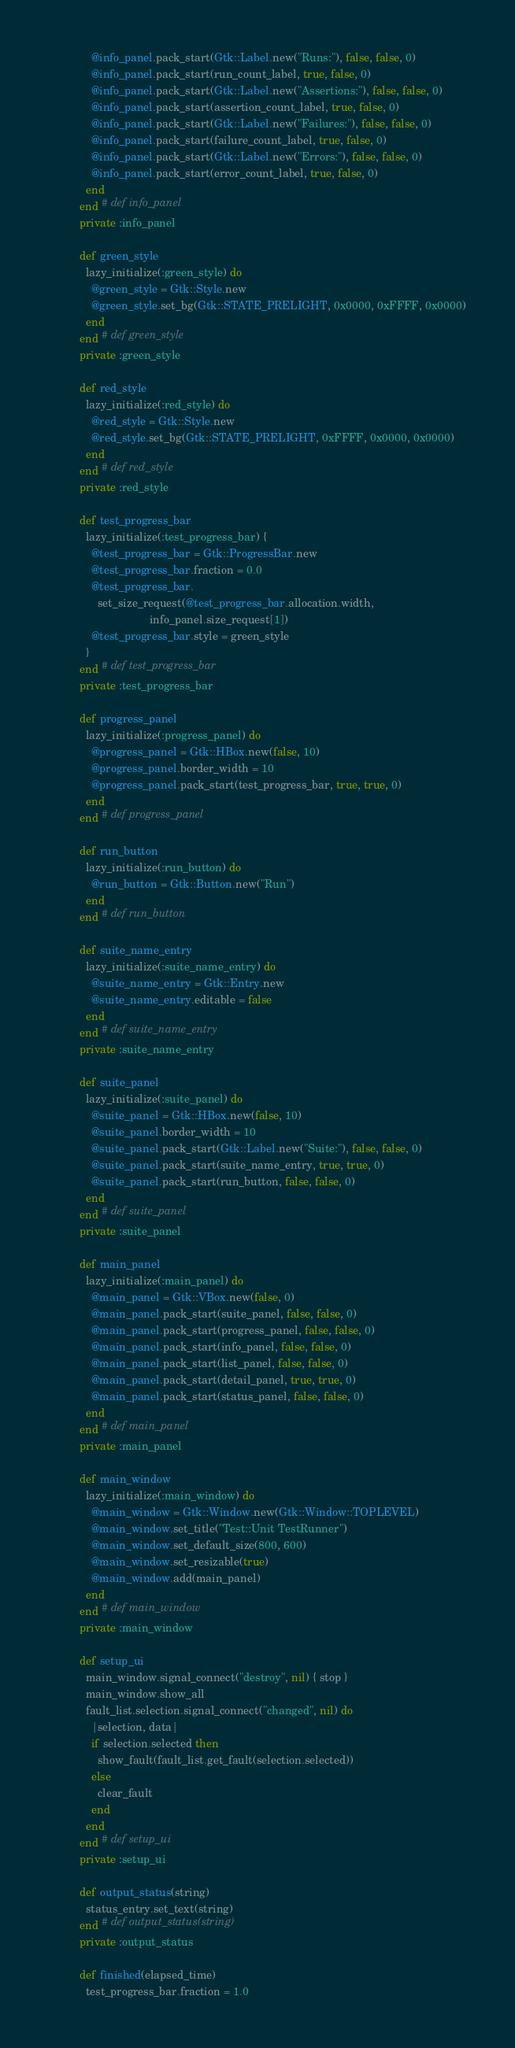Convert code to text. <code><loc_0><loc_0><loc_500><loc_500><_Ruby_>              @info_panel.pack_start(Gtk::Label.new("Runs:"), false, false, 0)
              @info_panel.pack_start(run_count_label, true, false, 0)
              @info_panel.pack_start(Gtk::Label.new("Assertions:"), false, false, 0)
              @info_panel.pack_start(assertion_count_label, true, false, 0)
              @info_panel.pack_start(Gtk::Label.new("Failures:"), false, false, 0)
              @info_panel.pack_start(failure_count_label, true, false, 0)
              @info_panel.pack_start(Gtk::Label.new("Errors:"), false, false, 0)
              @info_panel.pack_start(error_count_label, true, false, 0)
            end
          end # def info_panel
          private :info_panel

          def green_style
            lazy_initialize(:green_style) do
              @green_style = Gtk::Style.new
              @green_style.set_bg(Gtk::STATE_PRELIGHT, 0x0000, 0xFFFF, 0x0000)
            end
          end # def green_style
          private :green_style
          
          def red_style
            lazy_initialize(:red_style) do
              @red_style = Gtk::Style.new
              @red_style.set_bg(Gtk::STATE_PRELIGHT, 0xFFFF, 0x0000, 0x0000)
            end
          end # def red_style
          private :red_style
          
          def test_progress_bar
            lazy_initialize(:test_progress_bar) {
              @test_progress_bar = Gtk::ProgressBar.new
              @test_progress_bar.fraction = 0.0
              @test_progress_bar.
                set_size_request(@test_progress_bar.allocation.width,
                                 info_panel.size_request[1])
              @test_progress_bar.style = green_style
            }
          end # def test_progress_bar
          private :test_progress_bar
          
          def progress_panel
            lazy_initialize(:progress_panel) do
              @progress_panel = Gtk::HBox.new(false, 10)
              @progress_panel.border_width = 10
              @progress_panel.pack_start(test_progress_bar, true, true, 0)
            end
          end # def progress_panel

          def run_button
            lazy_initialize(:run_button) do
              @run_button = Gtk::Button.new("Run")
            end
          end # def run_button

          def suite_name_entry
            lazy_initialize(:suite_name_entry) do
              @suite_name_entry = Gtk::Entry.new
              @suite_name_entry.editable = false
            end
          end # def suite_name_entry
          private :suite_name_entry

          def suite_panel
            lazy_initialize(:suite_panel) do
              @suite_panel = Gtk::HBox.new(false, 10)
              @suite_panel.border_width = 10
              @suite_panel.pack_start(Gtk::Label.new("Suite:"), false, false, 0)
              @suite_panel.pack_start(suite_name_entry, true, true, 0)
              @suite_panel.pack_start(run_button, false, false, 0)
            end
          end # def suite_panel
          private :suite_panel

          def main_panel
            lazy_initialize(:main_panel) do
              @main_panel = Gtk::VBox.new(false, 0)
              @main_panel.pack_start(suite_panel, false, false, 0)
              @main_panel.pack_start(progress_panel, false, false, 0)
              @main_panel.pack_start(info_panel, false, false, 0)
              @main_panel.pack_start(list_panel, false, false, 0)
              @main_panel.pack_start(detail_panel, true, true, 0)
              @main_panel.pack_start(status_panel, false, false, 0)
            end
          end # def main_panel
          private :main_panel

          def main_window
            lazy_initialize(:main_window) do
              @main_window = Gtk::Window.new(Gtk::Window::TOPLEVEL)
              @main_window.set_title("Test::Unit TestRunner")
              @main_window.set_default_size(800, 600)
              @main_window.set_resizable(true)
              @main_window.add(main_panel)
            end
          end # def main_window
          private :main_window

          def setup_ui
            main_window.signal_connect("destroy", nil) { stop }
            main_window.show_all
            fault_list.selection.signal_connect("changed", nil) do
              |selection, data|
              if selection.selected then
                show_fault(fault_list.get_fault(selection.selected))
              else
                clear_fault
              end
            end
          end # def setup_ui
          private :setup_ui

          def output_status(string)
            status_entry.set_text(string)
          end # def output_status(string)
          private :output_status

          def finished(elapsed_time)
            test_progress_bar.fraction = 1.0</code> 